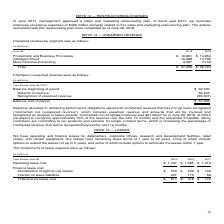According to Microsoft Corporation's financial document, Which places does the company have operating and finance leases? We have operating and finance leases for datacenters, corporate offices, research and development facilities, retail stores, and certain equipment.. The document states: "We have operating and finance leases for datacenters, corporate offices, research and development facilities, retail stores, and certain equipment. Ou..." Also, What is note 15 about? According to the financial document, LEASES. The relevant text states: "NOTE 15 — LEASES..." Also, How long are the remaining lease terms for? Our leases have remaining lease terms of 1 year to 20 years,. The document states: "facilities, retail stores, and certain equipment. Our leases have remaining lease terms of 1 year to 20 years, some of which include options to extend..." Also, How many finance lease cost items are there? Counting the relevant items in the document: Amortization of right-of-use assets,  Interest on lease liabilities, I find 2 instances. The key data points involved are: Amortization of right-of-use assets, Interest on lease liabilities. Also, can you calculate: How much will the operating lease cost be for 2020 if $507 million of leases could be terminated in 1 year? Based on the calculation: 1,707-507, the result is 1200 (in millions). This is based on the information: "Operating lease cost $ 1,707 $ 1,585 $ 1,412..." The key data points involved are: 1,707, 507. Additionally, What are the years sorted by total finance lease cost, in ascending order? The document contains multiple relevant values: 2019, 2018, 2017. From the document: "Year Ended June 30, 2019 2018 2017 Year Ended June 30, 2019 2018 2017 Year Ended June 30, 2019 2018 2017..." 